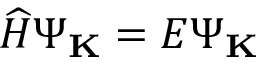Convert formula to latex. <formula><loc_0><loc_0><loc_500><loc_500>\widehat { H } \Psi _ { K } = E \Psi _ { K }</formula> 